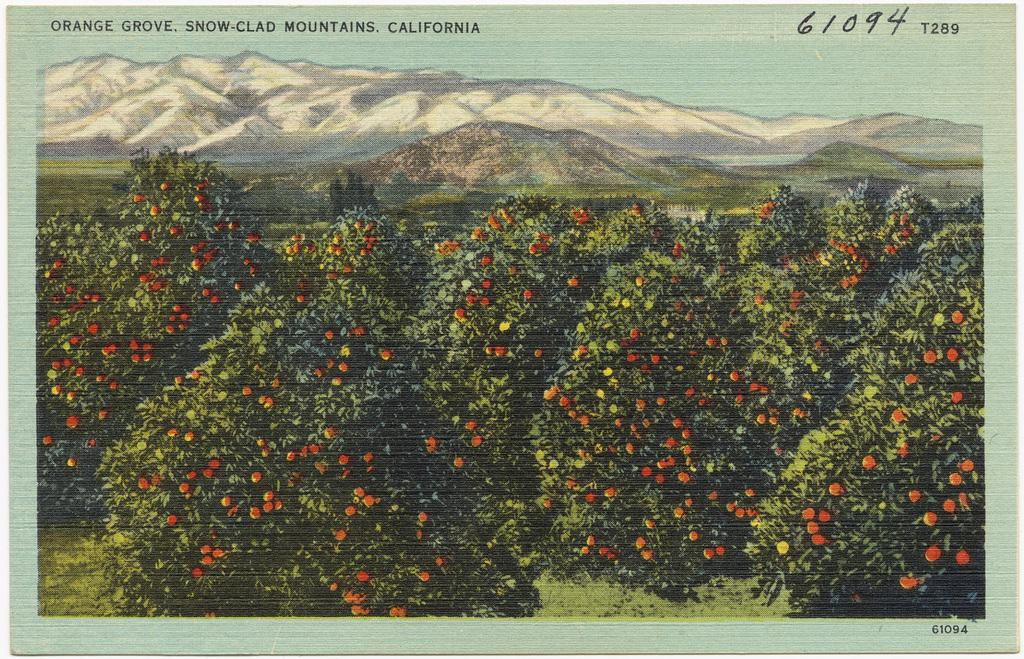What is the main structure in the image? There is a frame in the image. What can be seen in the background of the image? The sky, mountains, trees, and grass are visible in the image. What type of food is present in the image? There are fruits in the image. Is there any text on the image? Yes, there is text on the image. What type of game is being played in the image? There is no game being played in the image; it features a frame with a background and text. What type of vegetable can be seen growing in the image? There are no vegetables visible in the image; it features fruits, not vegetables. 